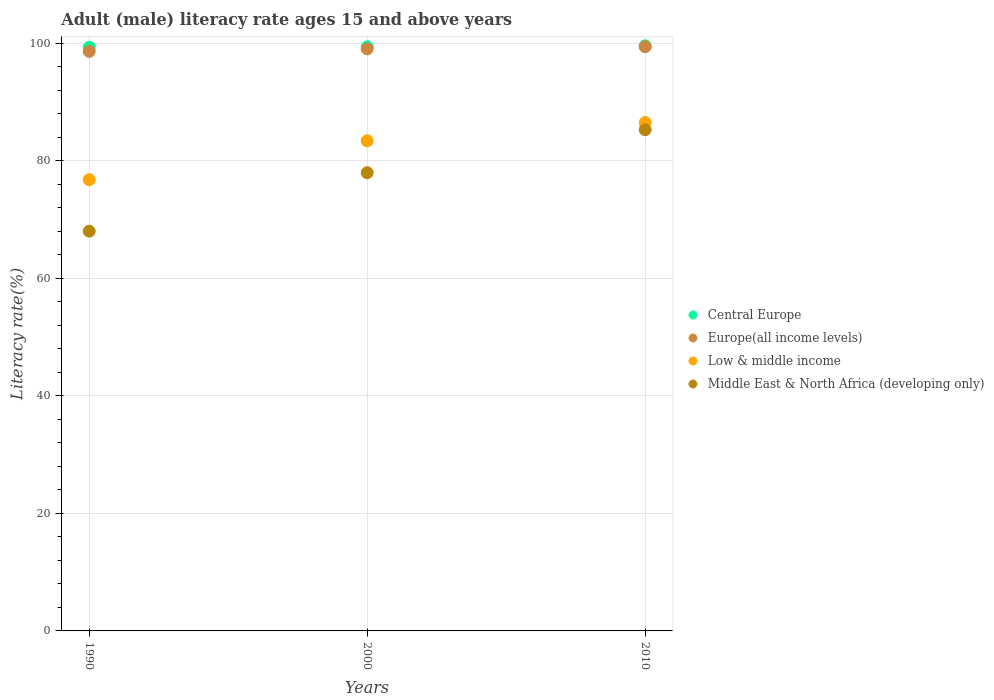How many different coloured dotlines are there?
Provide a succinct answer. 4. What is the adult male literacy rate in Central Europe in 1990?
Keep it short and to the point. 99.29. Across all years, what is the maximum adult male literacy rate in Central Europe?
Provide a succinct answer. 99.53. Across all years, what is the minimum adult male literacy rate in Central Europe?
Ensure brevity in your answer.  99.29. What is the total adult male literacy rate in Middle East & North Africa (developing only) in the graph?
Provide a short and direct response. 231.22. What is the difference between the adult male literacy rate in Middle East & North Africa (developing only) in 1990 and that in 2010?
Offer a terse response. -17.25. What is the difference between the adult male literacy rate in Middle East & North Africa (developing only) in 1990 and the adult male literacy rate in Central Europe in 2010?
Your answer should be compact. -31.53. What is the average adult male literacy rate in Middle East & North Africa (developing only) per year?
Offer a very short reply. 77.07. In the year 2010, what is the difference between the adult male literacy rate in Europe(all income levels) and adult male literacy rate in Low & middle income?
Your answer should be compact. 12.91. In how many years, is the adult male literacy rate in Europe(all income levels) greater than 24 %?
Provide a short and direct response. 3. What is the ratio of the adult male literacy rate in Europe(all income levels) in 2000 to that in 2010?
Your response must be concise. 1. What is the difference between the highest and the second highest adult male literacy rate in Low & middle income?
Make the answer very short. 3.1. What is the difference between the highest and the lowest adult male literacy rate in Low & middle income?
Ensure brevity in your answer.  9.72. In how many years, is the adult male literacy rate in Low & middle income greater than the average adult male literacy rate in Low & middle income taken over all years?
Your response must be concise. 2. Is the sum of the adult male literacy rate in Europe(all income levels) in 2000 and 2010 greater than the maximum adult male literacy rate in Middle East & North Africa (developing only) across all years?
Offer a terse response. Yes. Is it the case that in every year, the sum of the adult male literacy rate in Middle East & North Africa (developing only) and adult male literacy rate in Europe(all income levels)  is greater than the sum of adult male literacy rate in Central Europe and adult male literacy rate in Low & middle income?
Give a very brief answer. No. Is the adult male literacy rate in Middle East & North Africa (developing only) strictly greater than the adult male literacy rate in Low & middle income over the years?
Keep it short and to the point. No. How many dotlines are there?
Provide a short and direct response. 4. How many years are there in the graph?
Ensure brevity in your answer.  3. What is the difference between two consecutive major ticks on the Y-axis?
Your answer should be compact. 20. Are the values on the major ticks of Y-axis written in scientific E-notation?
Provide a short and direct response. No. Where does the legend appear in the graph?
Make the answer very short. Center right. What is the title of the graph?
Your response must be concise. Adult (male) literacy rate ages 15 and above years. What is the label or title of the Y-axis?
Your response must be concise. Literacy rate(%). What is the Literacy rate(%) in Central Europe in 1990?
Give a very brief answer. 99.29. What is the Literacy rate(%) in Europe(all income levels) in 1990?
Offer a terse response. 98.6. What is the Literacy rate(%) of Low & middle income in 1990?
Your answer should be very brief. 76.76. What is the Literacy rate(%) of Middle East & North Africa (developing only) in 1990?
Your response must be concise. 68.01. What is the Literacy rate(%) of Central Europe in 2000?
Offer a terse response. 99.36. What is the Literacy rate(%) of Europe(all income levels) in 2000?
Offer a terse response. 99.01. What is the Literacy rate(%) of Low & middle income in 2000?
Your answer should be compact. 83.38. What is the Literacy rate(%) in Middle East & North Africa (developing only) in 2000?
Provide a short and direct response. 77.95. What is the Literacy rate(%) of Central Europe in 2010?
Provide a succinct answer. 99.53. What is the Literacy rate(%) of Europe(all income levels) in 2010?
Ensure brevity in your answer.  99.39. What is the Literacy rate(%) in Low & middle income in 2010?
Ensure brevity in your answer.  86.48. What is the Literacy rate(%) in Middle East & North Africa (developing only) in 2010?
Keep it short and to the point. 85.26. Across all years, what is the maximum Literacy rate(%) in Central Europe?
Provide a succinct answer. 99.53. Across all years, what is the maximum Literacy rate(%) in Europe(all income levels)?
Give a very brief answer. 99.39. Across all years, what is the maximum Literacy rate(%) of Low & middle income?
Offer a very short reply. 86.48. Across all years, what is the maximum Literacy rate(%) of Middle East & North Africa (developing only)?
Your response must be concise. 85.26. Across all years, what is the minimum Literacy rate(%) of Central Europe?
Give a very brief answer. 99.29. Across all years, what is the minimum Literacy rate(%) in Europe(all income levels)?
Your answer should be compact. 98.6. Across all years, what is the minimum Literacy rate(%) in Low & middle income?
Offer a very short reply. 76.76. Across all years, what is the minimum Literacy rate(%) of Middle East & North Africa (developing only)?
Provide a succinct answer. 68.01. What is the total Literacy rate(%) of Central Europe in the graph?
Provide a succinct answer. 298.19. What is the total Literacy rate(%) of Europe(all income levels) in the graph?
Your answer should be very brief. 297. What is the total Literacy rate(%) in Low & middle income in the graph?
Keep it short and to the point. 246.63. What is the total Literacy rate(%) in Middle East & North Africa (developing only) in the graph?
Provide a short and direct response. 231.22. What is the difference between the Literacy rate(%) of Central Europe in 1990 and that in 2000?
Offer a terse response. -0.07. What is the difference between the Literacy rate(%) of Europe(all income levels) in 1990 and that in 2000?
Make the answer very short. -0.41. What is the difference between the Literacy rate(%) in Low & middle income in 1990 and that in 2000?
Your answer should be very brief. -6.62. What is the difference between the Literacy rate(%) in Middle East & North Africa (developing only) in 1990 and that in 2000?
Provide a short and direct response. -9.95. What is the difference between the Literacy rate(%) of Central Europe in 1990 and that in 2010?
Give a very brief answer. -0.24. What is the difference between the Literacy rate(%) in Europe(all income levels) in 1990 and that in 2010?
Your response must be concise. -0.79. What is the difference between the Literacy rate(%) in Low & middle income in 1990 and that in 2010?
Give a very brief answer. -9.72. What is the difference between the Literacy rate(%) in Middle East & North Africa (developing only) in 1990 and that in 2010?
Provide a short and direct response. -17.25. What is the difference between the Literacy rate(%) of Central Europe in 2000 and that in 2010?
Provide a short and direct response. -0.17. What is the difference between the Literacy rate(%) of Europe(all income levels) in 2000 and that in 2010?
Offer a very short reply. -0.38. What is the difference between the Literacy rate(%) of Low & middle income in 2000 and that in 2010?
Ensure brevity in your answer.  -3.1. What is the difference between the Literacy rate(%) of Middle East & North Africa (developing only) in 2000 and that in 2010?
Your answer should be compact. -7.31. What is the difference between the Literacy rate(%) in Central Europe in 1990 and the Literacy rate(%) in Europe(all income levels) in 2000?
Your answer should be very brief. 0.28. What is the difference between the Literacy rate(%) in Central Europe in 1990 and the Literacy rate(%) in Low & middle income in 2000?
Keep it short and to the point. 15.91. What is the difference between the Literacy rate(%) in Central Europe in 1990 and the Literacy rate(%) in Middle East & North Africa (developing only) in 2000?
Offer a terse response. 21.34. What is the difference between the Literacy rate(%) of Europe(all income levels) in 1990 and the Literacy rate(%) of Low & middle income in 2000?
Provide a succinct answer. 15.22. What is the difference between the Literacy rate(%) in Europe(all income levels) in 1990 and the Literacy rate(%) in Middle East & North Africa (developing only) in 2000?
Make the answer very short. 20.65. What is the difference between the Literacy rate(%) in Low & middle income in 1990 and the Literacy rate(%) in Middle East & North Africa (developing only) in 2000?
Give a very brief answer. -1.19. What is the difference between the Literacy rate(%) of Central Europe in 1990 and the Literacy rate(%) of Europe(all income levels) in 2010?
Keep it short and to the point. -0.09. What is the difference between the Literacy rate(%) in Central Europe in 1990 and the Literacy rate(%) in Low & middle income in 2010?
Offer a very short reply. 12.81. What is the difference between the Literacy rate(%) in Central Europe in 1990 and the Literacy rate(%) in Middle East & North Africa (developing only) in 2010?
Provide a short and direct response. 14.04. What is the difference between the Literacy rate(%) of Europe(all income levels) in 1990 and the Literacy rate(%) of Low & middle income in 2010?
Offer a very short reply. 12.12. What is the difference between the Literacy rate(%) of Europe(all income levels) in 1990 and the Literacy rate(%) of Middle East & North Africa (developing only) in 2010?
Keep it short and to the point. 13.34. What is the difference between the Literacy rate(%) of Low & middle income in 1990 and the Literacy rate(%) of Middle East & North Africa (developing only) in 2010?
Offer a terse response. -8.49. What is the difference between the Literacy rate(%) of Central Europe in 2000 and the Literacy rate(%) of Europe(all income levels) in 2010?
Your answer should be very brief. -0.03. What is the difference between the Literacy rate(%) in Central Europe in 2000 and the Literacy rate(%) in Low & middle income in 2010?
Your response must be concise. 12.88. What is the difference between the Literacy rate(%) in Central Europe in 2000 and the Literacy rate(%) in Middle East & North Africa (developing only) in 2010?
Your response must be concise. 14.1. What is the difference between the Literacy rate(%) in Europe(all income levels) in 2000 and the Literacy rate(%) in Low & middle income in 2010?
Your response must be concise. 12.53. What is the difference between the Literacy rate(%) of Europe(all income levels) in 2000 and the Literacy rate(%) of Middle East & North Africa (developing only) in 2010?
Your response must be concise. 13.75. What is the difference between the Literacy rate(%) of Low & middle income in 2000 and the Literacy rate(%) of Middle East & North Africa (developing only) in 2010?
Make the answer very short. -1.88. What is the average Literacy rate(%) in Central Europe per year?
Your answer should be very brief. 99.4. What is the average Literacy rate(%) in Europe(all income levels) per year?
Offer a very short reply. 99. What is the average Literacy rate(%) of Low & middle income per year?
Offer a very short reply. 82.21. What is the average Literacy rate(%) in Middle East & North Africa (developing only) per year?
Offer a terse response. 77.07. In the year 1990, what is the difference between the Literacy rate(%) in Central Europe and Literacy rate(%) in Europe(all income levels)?
Your response must be concise. 0.7. In the year 1990, what is the difference between the Literacy rate(%) of Central Europe and Literacy rate(%) of Low & middle income?
Offer a very short reply. 22.53. In the year 1990, what is the difference between the Literacy rate(%) of Central Europe and Literacy rate(%) of Middle East & North Africa (developing only)?
Ensure brevity in your answer.  31.29. In the year 1990, what is the difference between the Literacy rate(%) of Europe(all income levels) and Literacy rate(%) of Low & middle income?
Provide a short and direct response. 21.84. In the year 1990, what is the difference between the Literacy rate(%) of Europe(all income levels) and Literacy rate(%) of Middle East & North Africa (developing only)?
Provide a succinct answer. 30.59. In the year 1990, what is the difference between the Literacy rate(%) of Low & middle income and Literacy rate(%) of Middle East & North Africa (developing only)?
Your response must be concise. 8.76. In the year 2000, what is the difference between the Literacy rate(%) of Central Europe and Literacy rate(%) of Europe(all income levels)?
Offer a terse response. 0.35. In the year 2000, what is the difference between the Literacy rate(%) in Central Europe and Literacy rate(%) in Low & middle income?
Your answer should be compact. 15.98. In the year 2000, what is the difference between the Literacy rate(%) of Central Europe and Literacy rate(%) of Middle East & North Africa (developing only)?
Make the answer very short. 21.41. In the year 2000, what is the difference between the Literacy rate(%) in Europe(all income levels) and Literacy rate(%) in Low & middle income?
Ensure brevity in your answer.  15.63. In the year 2000, what is the difference between the Literacy rate(%) in Europe(all income levels) and Literacy rate(%) in Middle East & North Africa (developing only)?
Your response must be concise. 21.06. In the year 2000, what is the difference between the Literacy rate(%) in Low & middle income and Literacy rate(%) in Middle East & North Africa (developing only)?
Offer a very short reply. 5.43. In the year 2010, what is the difference between the Literacy rate(%) in Central Europe and Literacy rate(%) in Europe(all income levels)?
Make the answer very short. 0.15. In the year 2010, what is the difference between the Literacy rate(%) of Central Europe and Literacy rate(%) of Low & middle income?
Make the answer very short. 13.05. In the year 2010, what is the difference between the Literacy rate(%) in Central Europe and Literacy rate(%) in Middle East & North Africa (developing only)?
Give a very brief answer. 14.28. In the year 2010, what is the difference between the Literacy rate(%) of Europe(all income levels) and Literacy rate(%) of Low & middle income?
Give a very brief answer. 12.91. In the year 2010, what is the difference between the Literacy rate(%) of Europe(all income levels) and Literacy rate(%) of Middle East & North Africa (developing only)?
Your answer should be very brief. 14.13. In the year 2010, what is the difference between the Literacy rate(%) in Low & middle income and Literacy rate(%) in Middle East & North Africa (developing only)?
Provide a short and direct response. 1.22. What is the ratio of the Literacy rate(%) in Central Europe in 1990 to that in 2000?
Provide a short and direct response. 1. What is the ratio of the Literacy rate(%) in Europe(all income levels) in 1990 to that in 2000?
Your answer should be compact. 1. What is the ratio of the Literacy rate(%) of Low & middle income in 1990 to that in 2000?
Offer a terse response. 0.92. What is the ratio of the Literacy rate(%) of Middle East & North Africa (developing only) in 1990 to that in 2000?
Make the answer very short. 0.87. What is the ratio of the Literacy rate(%) in Central Europe in 1990 to that in 2010?
Keep it short and to the point. 1. What is the ratio of the Literacy rate(%) in Low & middle income in 1990 to that in 2010?
Ensure brevity in your answer.  0.89. What is the ratio of the Literacy rate(%) in Middle East & North Africa (developing only) in 1990 to that in 2010?
Offer a terse response. 0.8. What is the ratio of the Literacy rate(%) of Central Europe in 2000 to that in 2010?
Offer a very short reply. 1. What is the ratio of the Literacy rate(%) in Europe(all income levels) in 2000 to that in 2010?
Ensure brevity in your answer.  1. What is the ratio of the Literacy rate(%) in Low & middle income in 2000 to that in 2010?
Ensure brevity in your answer.  0.96. What is the ratio of the Literacy rate(%) in Middle East & North Africa (developing only) in 2000 to that in 2010?
Provide a short and direct response. 0.91. What is the difference between the highest and the second highest Literacy rate(%) of Central Europe?
Make the answer very short. 0.17. What is the difference between the highest and the second highest Literacy rate(%) of Europe(all income levels)?
Your answer should be very brief. 0.38. What is the difference between the highest and the second highest Literacy rate(%) in Low & middle income?
Ensure brevity in your answer.  3.1. What is the difference between the highest and the second highest Literacy rate(%) in Middle East & North Africa (developing only)?
Your answer should be compact. 7.31. What is the difference between the highest and the lowest Literacy rate(%) in Central Europe?
Your answer should be compact. 0.24. What is the difference between the highest and the lowest Literacy rate(%) of Europe(all income levels)?
Offer a very short reply. 0.79. What is the difference between the highest and the lowest Literacy rate(%) of Low & middle income?
Your response must be concise. 9.72. What is the difference between the highest and the lowest Literacy rate(%) in Middle East & North Africa (developing only)?
Keep it short and to the point. 17.25. 